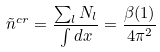<formula> <loc_0><loc_0><loc_500><loc_500>\tilde { n } ^ { c r } = \frac { \sum _ { l } N _ { l } } { \int d { x } } = \frac { \beta ( 1 ) } { 4 \pi ^ { 2 } }</formula> 